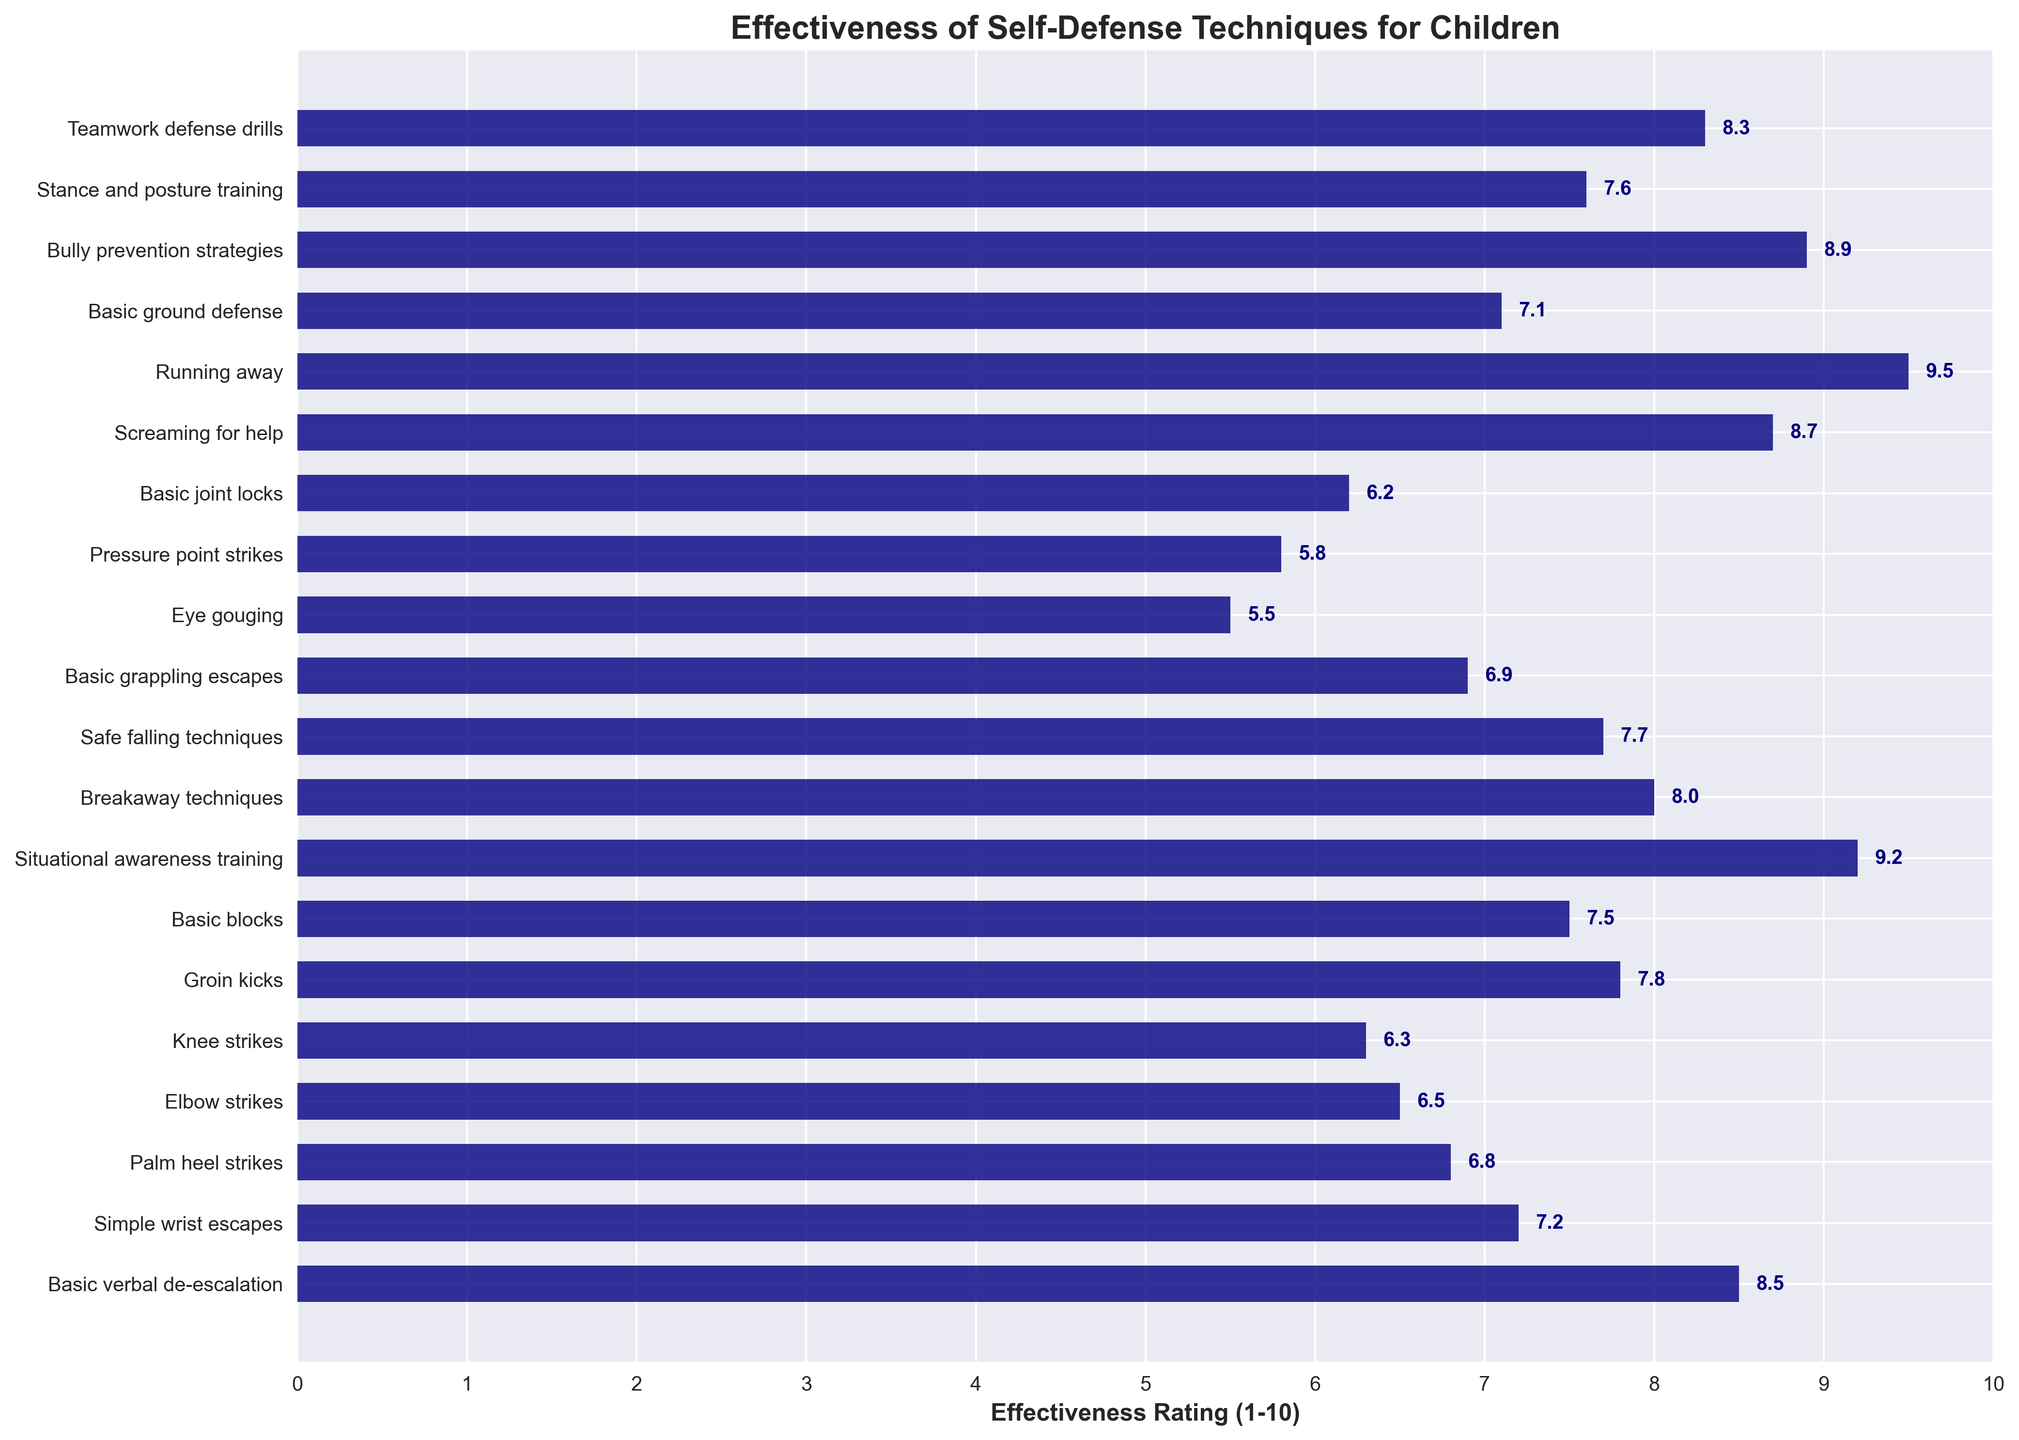What is the highest effectiveness rating shown in the chart? The highest effectiveness rating can be seen by looking for the bar that reaches the farthest to the right on the x-axis.
Answer: 9.5 Which technique is rated the least effective? The technique rated the least effective is represented by the shortest bar on the chart.
Answer: Eye gouging Which techniques have an effectiveness rating greater than 8? Techniques with an effectiveness rating greater than 8 have bars extending beyond the 8 mark on the x-axis. These include 'Basic verbal de-escalation', 'Situational awareness training', 'Screaming for help', 'Running away', 'Bully prevention strategies', and 'Teamwork defense drills'.
Answer: Six techniques What is the difference in the effectiveness rating between 'Basic verbal de-escalation' and 'Groin kicks'? Subtract the effectiveness rating of 'Groin kicks' from that of 'Basic verbal de-escalation'. (8.5 - 7.8 = 0.7)
Answer: 0.7 On average, how effective are the techniques with ratings above 7? First list all the techniques with ratings above 7: 'Basic verbal de-escalation' (8.5), 'Groin kicks' (7.8), 'Basic blocks' (7.5), 'Situational awareness training' (9.2), 'Breakaway techniques' (8.0), 'Safe falling techniques' (7.7), 'Screaming for help' (8.7), 'Running away' (9.5), 'Bully prevention strategies' (8.9), 'Stance and posture training' (7.6), 'Teamwork defense drills' (8.3). Calculate the average: (8.5 + 7.8 + 7.5 + 9.2 + 8.0 + 7.7 + 8.7 + 9.5 + 8.9 + 7.6 + 8.3) / 11 = 8.26
Answer: 8.26 Which two techniques have exactly the same effectiveness rating? By comparing the lengths of the bars, we can identify that 'Simple wrist escapes' and 'Basic ground defense' both have a rating of 7.2.
Answer: None Is 'Teamwork defense drills' rated higher than 'Basic joint locks'? Compare the bars for 'Teamwork defense drills' and 'Basic joint locks'. 'Teamwork defense drills' reaches an effectiveness rating of 8.3, while 'Basic joint locks' is at 6.2.
Answer: Yes What is the total effectiveness rating of 'Knee strikes', 'Groin kicks', and 'Basic blocks'? Add the effectiveness ratings for the three techniques: 6.3 (Knee strikes) + 7.8 (Groin kicks) + 7.5 (Basic blocks) = 21.6
Answer: 21.6 How many techniques have an effectiveness rating less than 6? Techniques with ratings less than 6 can be identified by short bars ending before the 6 mark on the x-axis. These include 'Eye gouging' (5.5) and 'Pressure point strikes' (5.8).
Answer: Two 